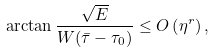<formula> <loc_0><loc_0><loc_500><loc_500>\arctan \frac { \sqrt { E } } { W ( \bar { \tau } - \tau _ { 0 } ) } \leq O \left ( \eta ^ { r } \right ) ,</formula> 